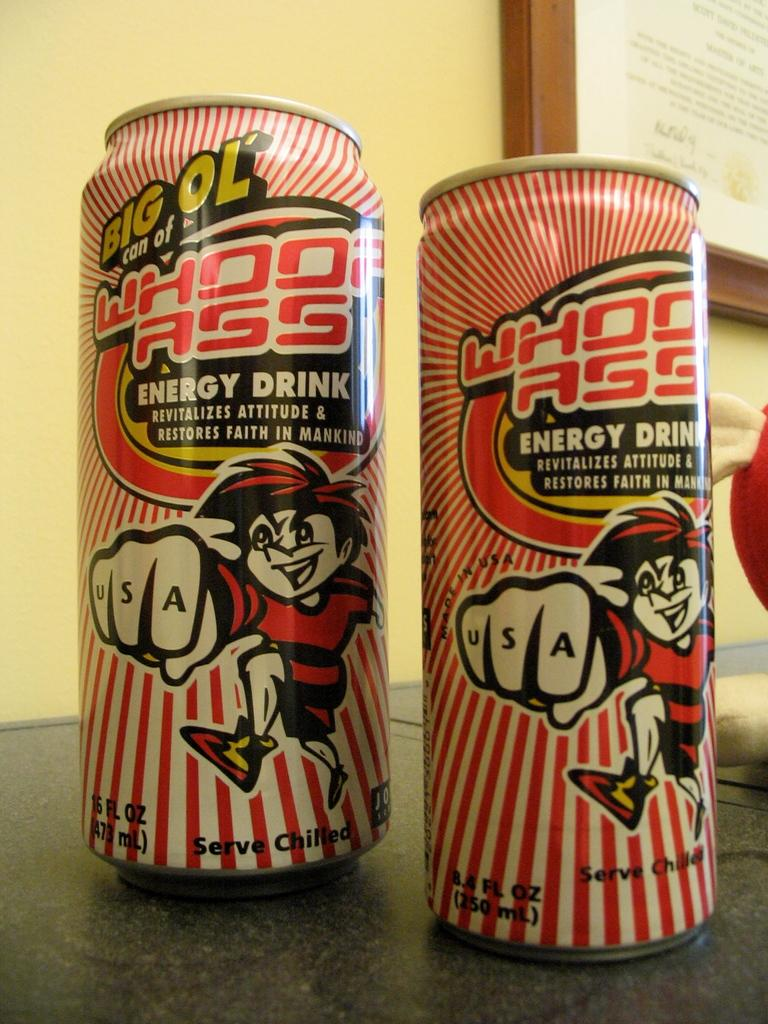Provide a one-sentence caption for the provided image. Two cans with a cartoon character showing USA written on his knuckles. 